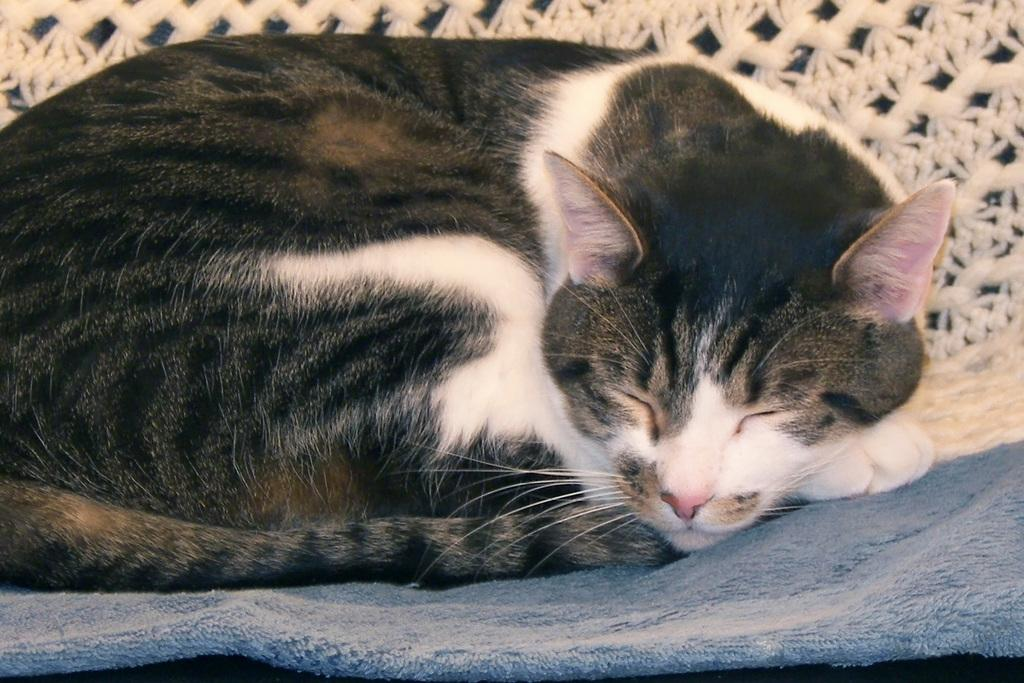What type of animal is in the image? There is a cat in the image. What is the cat doing in the image? The cat has its eyes closed. How many toes does the monkey have in the image? There is no monkey present in the image, so it is not possible to determine the number of toes it might have. 